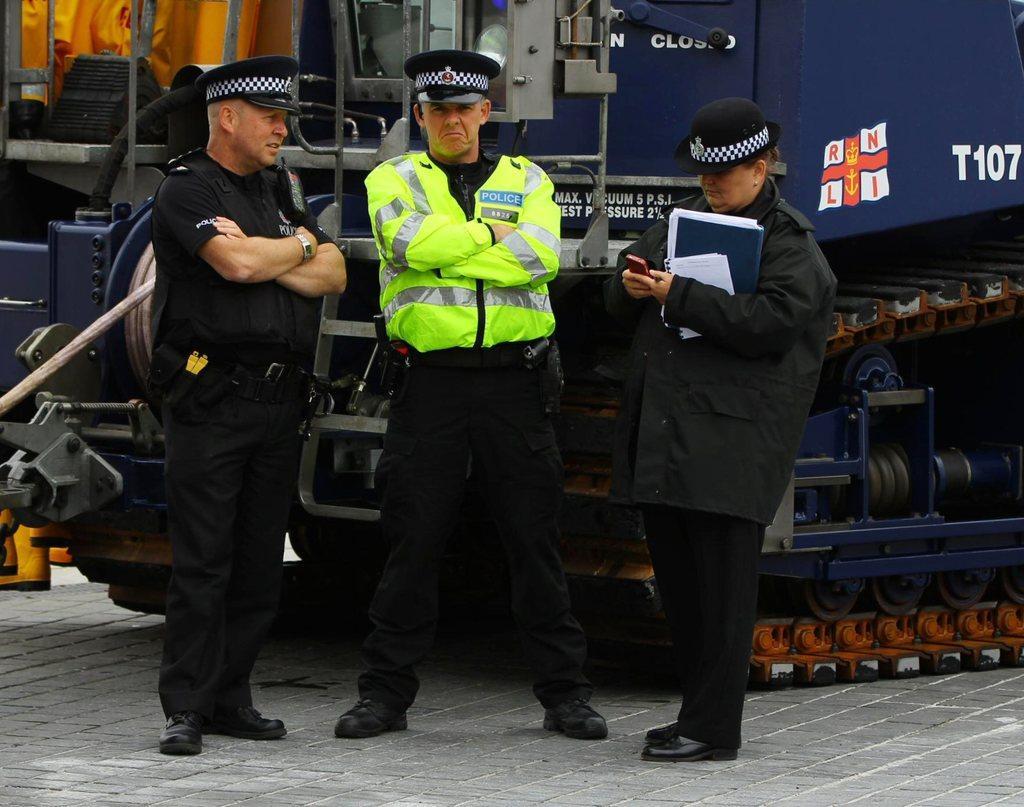Can you describe this image briefly? In this image there are persons standing. In the background there is a vehicle, there is a woman standing and holding objects in her hand. 